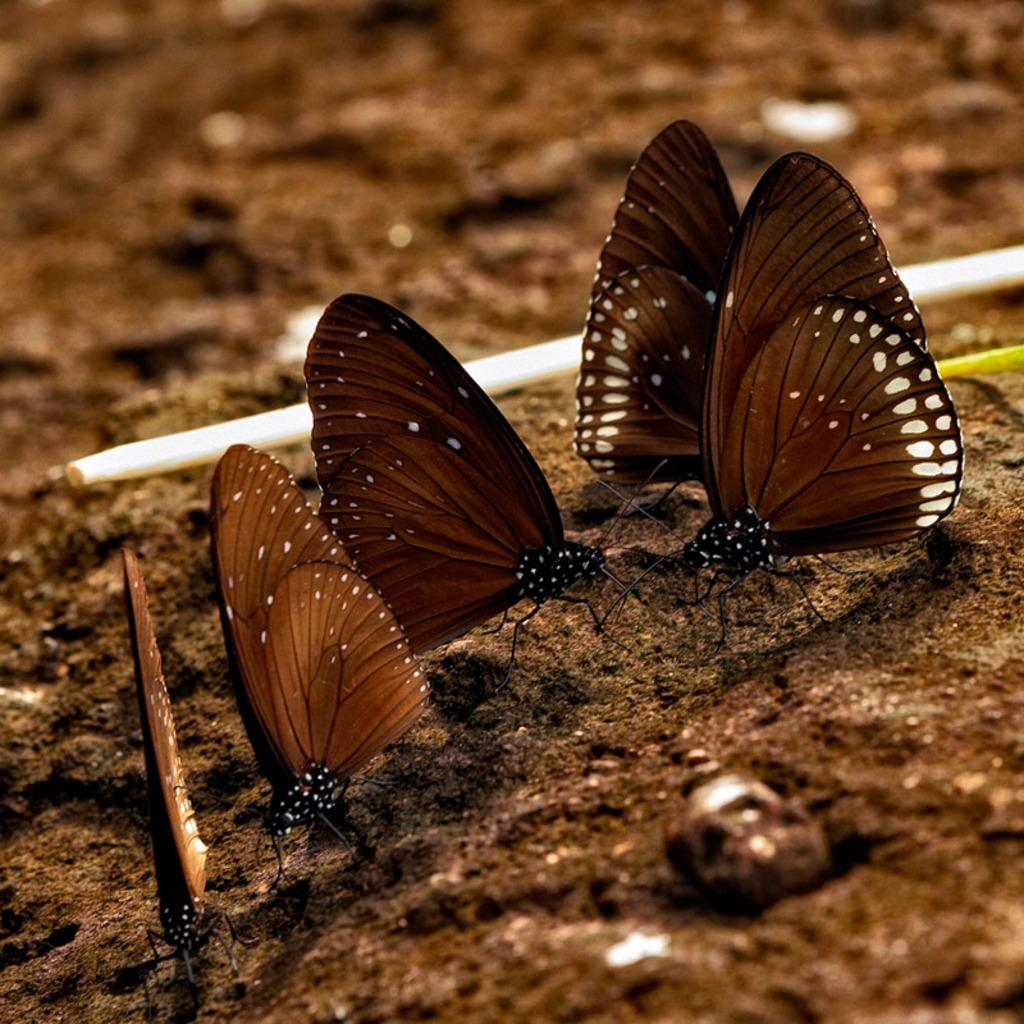How many butterflies are on the ground in the image? There are five butterflies on the ground in the image. What else can be seen on the ground in the image? There is a stick on the ground in the image. Can you describe the top part of the image? The top part of the image is blurry. What type of note is being played by the frogs in the image? There are no frogs present in the image, so there is no note being played. Can you see a rifle in the image? There is no rifle present in the image. 